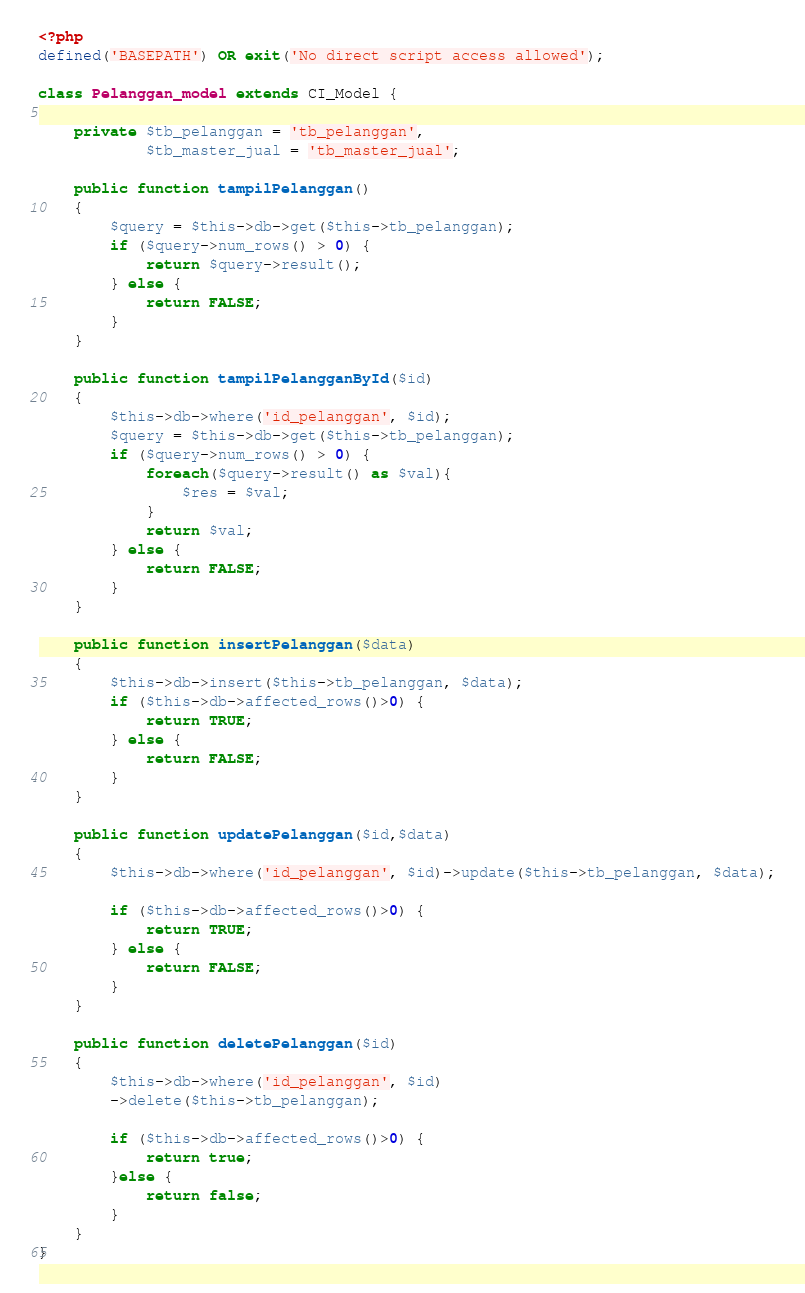Convert code to text. <code><loc_0><loc_0><loc_500><loc_500><_PHP_><?php
defined('BASEPATH') OR exit('No direct script access allowed');

class Pelanggan_model extends CI_Model {

	private $tb_pelanggan = 'tb_pelanggan',
			$tb_master_jual = 'tb_master_jual';
	
	public function tampilPelanggan()
	{
		$query = $this->db->get($this->tb_pelanggan);
		if ($query->num_rows() > 0) {
			return $query->result();
		} else {
			return FALSE;
		}
	}

	public function tampilPelangganById($id)
	{
		$this->db->where('id_pelanggan', $id);
		$query = $this->db->get($this->tb_pelanggan);
		if ($query->num_rows() > 0) {
			foreach($query->result() as $val){
				$res = $val;
			}
			return $val;
		} else {
			return FALSE;
		}
	}

	public function insertPelanggan($data)
	{
		$this->db->insert($this->tb_pelanggan, $data);
		if ($this->db->affected_rows()>0) {
			return TRUE;
		} else {
			return FALSE;
		}
	}

	public function updatePelanggan($id,$data)
	{
		$this->db->where('id_pelanggan', $id)->update($this->tb_pelanggan, $data);
		
		if ($this->db->affected_rows()>0) {
			return TRUE;
		} else {
			return FALSE;
		}
	}

	public function deletePelanggan($id)
	{
		$this->db->where('id_pelanggan', $id)
		->delete($this->tb_pelanggan);

		if ($this->db->affected_rows()>0) {
			return true;
		}else {
			return false;
		}
	}
}

</code> 